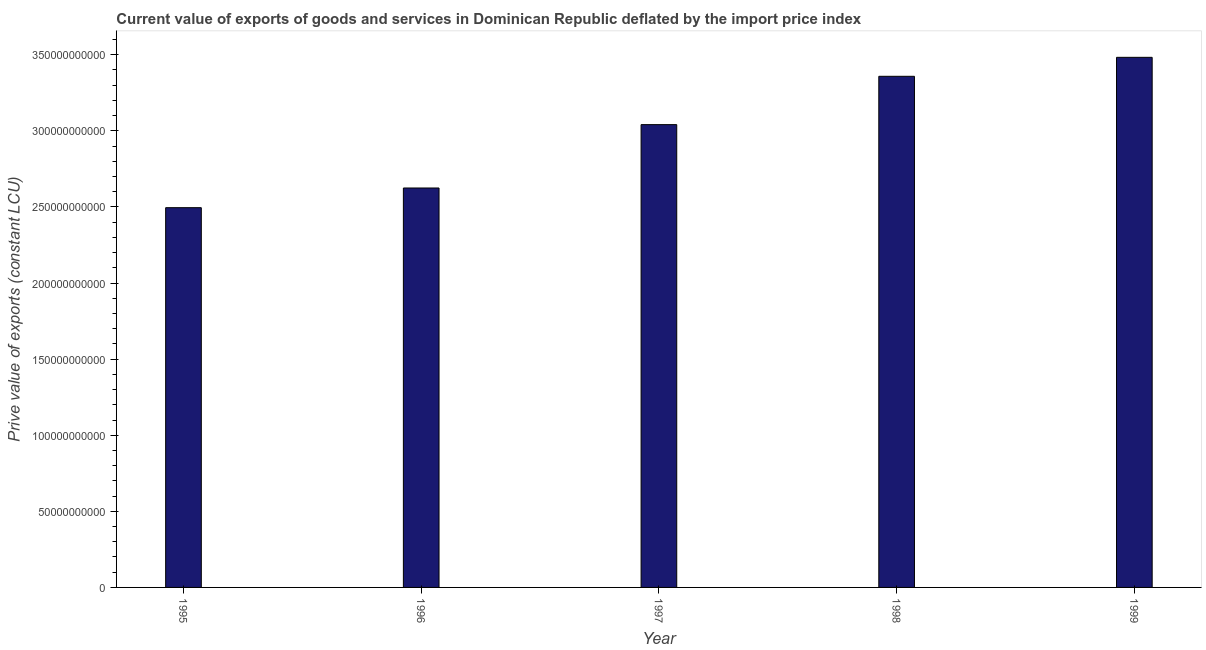Does the graph contain any zero values?
Your answer should be very brief. No. What is the title of the graph?
Keep it short and to the point. Current value of exports of goods and services in Dominican Republic deflated by the import price index. What is the label or title of the X-axis?
Keep it short and to the point. Year. What is the label or title of the Y-axis?
Make the answer very short. Prive value of exports (constant LCU). What is the price value of exports in 1998?
Offer a very short reply. 3.36e+11. Across all years, what is the maximum price value of exports?
Keep it short and to the point. 3.48e+11. Across all years, what is the minimum price value of exports?
Offer a very short reply. 2.50e+11. In which year was the price value of exports maximum?
Make the answer very short. 1999. What is the sum of the price value of exports?
Ensure brevity in your answer.  1.50e+12. What is the difference between the price value of exports in 1995 and 1998?
Provide a short and direct response. -8.63e+1. What is the average price value of exports per year?
Provide a short and direct response. 3.00e+11. What is the median price value of exports?
Your response must be concise. 3.04e+11. In how many years, is the price value of exports greater than 150000000000 LCU?
Ensure brevity in your answer.  5. What is the ratio of the price value of exports in 1997 to that in 1998?
Ensure brevity in your answer.  0.91. Is the price value of exports in 1995 less than that in 1998?
Make the answer very short. Yes. What is the difference between the highest and the second highest price value of exports?
Offer a terse response. 1.25e+1. Is the sum of the price value of exports in 1995 and 1999 greater than the maximum price value of exports across all years?
Provide a succinct answer. Yes. What is the difference between the highest and the lowest price value of exports?
Your answer should be very brief. 9.88e+1. How many years are there in the graph?
Ensure brevity in your answer.  5. What is the difference between two consecutive major ticks on the Y-axis?
Keep it short and to the point. 5.00e+1. What is the Prive value of exports (constant LCU) of 1995?
Keep it short and to the point. 2.50e+11. What is the Prive value of exports (constant LCU) of 1996?
Ensure brevity in your answer.  2.62e+11. What is the Prive value of exports (constant LCU) of 1997?
Make the answer very short. 3.04e+11. What is the Prive value of exports (constant LCU) of 1998?
Provide a short and direct response. 3.36e+11. What is the Prive value of exports (constant LCU) in 1999?
Make the answer very short. 3.48e+11. What is the difference between the Prive value of exports (constant LCU) in 1995 and 1996?
Provide a succinct answer. -1.29e+1. What is the difference between the Prive value of exports (constant LCU) in 1995 and 1997?
Provide a short and direct response. -5.46e+1. What is the difference between the Prive value of exports (constant LCU) in 1995 and 1998?
Provide a short and direct response. -8.63e+1. What is the difference between the Prive value of exports (constant LCU) in 1995 and 1999?
Your answer should be compact. -9.88e+1. What is the difference between the Prive value of exports (constant LCU) in 1996 and 1997?
Your answer should be very brief. -4.16e+1. What is the difference between the Prive value of exports (constant LCU) in 1996 and 1998?
Your answer should be very brief. -7.34e+1. What is the difference between the Prive value of exports (constant LCU) in 1996 and 1999?
Your response must be concise. -8.59e+1. What is the difference between the Prive value of exports (constant LCU) in 1997 and 1998?
Give a very brief answer. -3.18e+1. What is the difference between the Prive value of exports (constant LCU) in 1997 and 1999?
Keep it short and to the point. -4.42e+1. What is the difference between the Prive value of exports (constant LCU) in 1998 and 1999?
Make the answer very short. -1.25e+1. What is the ratio of the Prive value of exports (constant LCU) in 1995 to that in 1996?
Ensure brevity in your answer.  0.95. What is the ratio of the Prive value of exports (constant LCU) in 1995 to that in 1997?
Your answer should be very brief. 0.82. What is the ratio of the Prive value of exports (constant LCU) in 1995 to that in 1998?
Make the answer very short. 0.74. What is the ratio of the Prive value of exports (constant LCU) in 1995 to that in 1999?
Your response must be concise. 0.72. What is the ratio of the Prive value of exports (constant LCU) in 1996 to that in 1997?
Provide a succinct answer. 0.86. What is the ratio of the Prive value of exports (constant LCU) in 1996 to that in 1998?
Your response must be concise. 0.78. What is the ratio of the Prive value of exports (constant LCU) in 1996 to that in 1999?
Your response must be concise. 0.75. What is the ratio of the Prive value of exports (constant LCU) in 1997 to that in 1998?
Your answer should be compact. 0.91. What is the ratio of the Prive value of exports (constant LCU) in 1997 to that in 1999?
Offer a terse response. 0.87. 